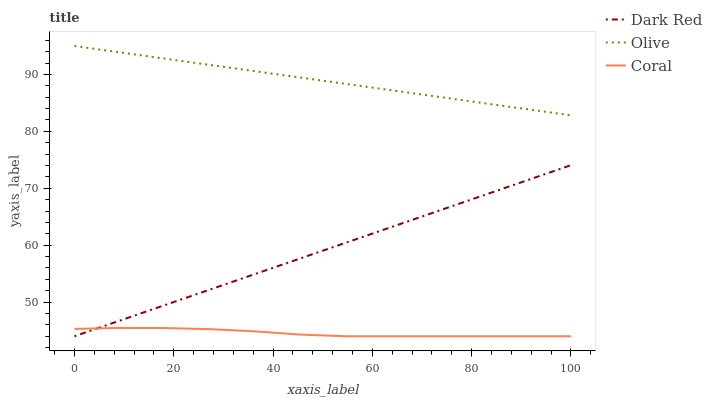Does Coral have the minimum area under the curve?
Answer yes or no. Yes. Does Olive have the maximum area under the curve?
Answer yes or no. Yes. Does Dark Red have the minimum area under the curve?
Answer yes or no. No. Does Dark Red have the maximum area under the curve?
Answer yes or no. No. Is Dark Red the smoothest?
Answer yes or no. Yes. Is Coral the roughest?
Answer yes or no. Yes. Is Coral the smoothest?
Answer yes or no. No. Is Dark Red the roughest?
Answer yes or no. No. Does Dark Red have the lowest value?
Answer yes or no. Yes. Does Olive have the highest value?
Answer yes or no. Yes. Does Dark Red have the highest value?
Answer yes or no. No. Is Coral less than Olive?
Answer yes or no. Yes. Is Olive greater than Coral?
Answer yes or no. Yes. Does Coral intersect Dark Red?
Answer yes or no. Yes. Is Coral less than Dark Red?
Answer yes or no. No. Is Coral greater than Dark Red?
Answer yes or no. No. Does Coral intersect Olive?
Answer yes or no. No. 